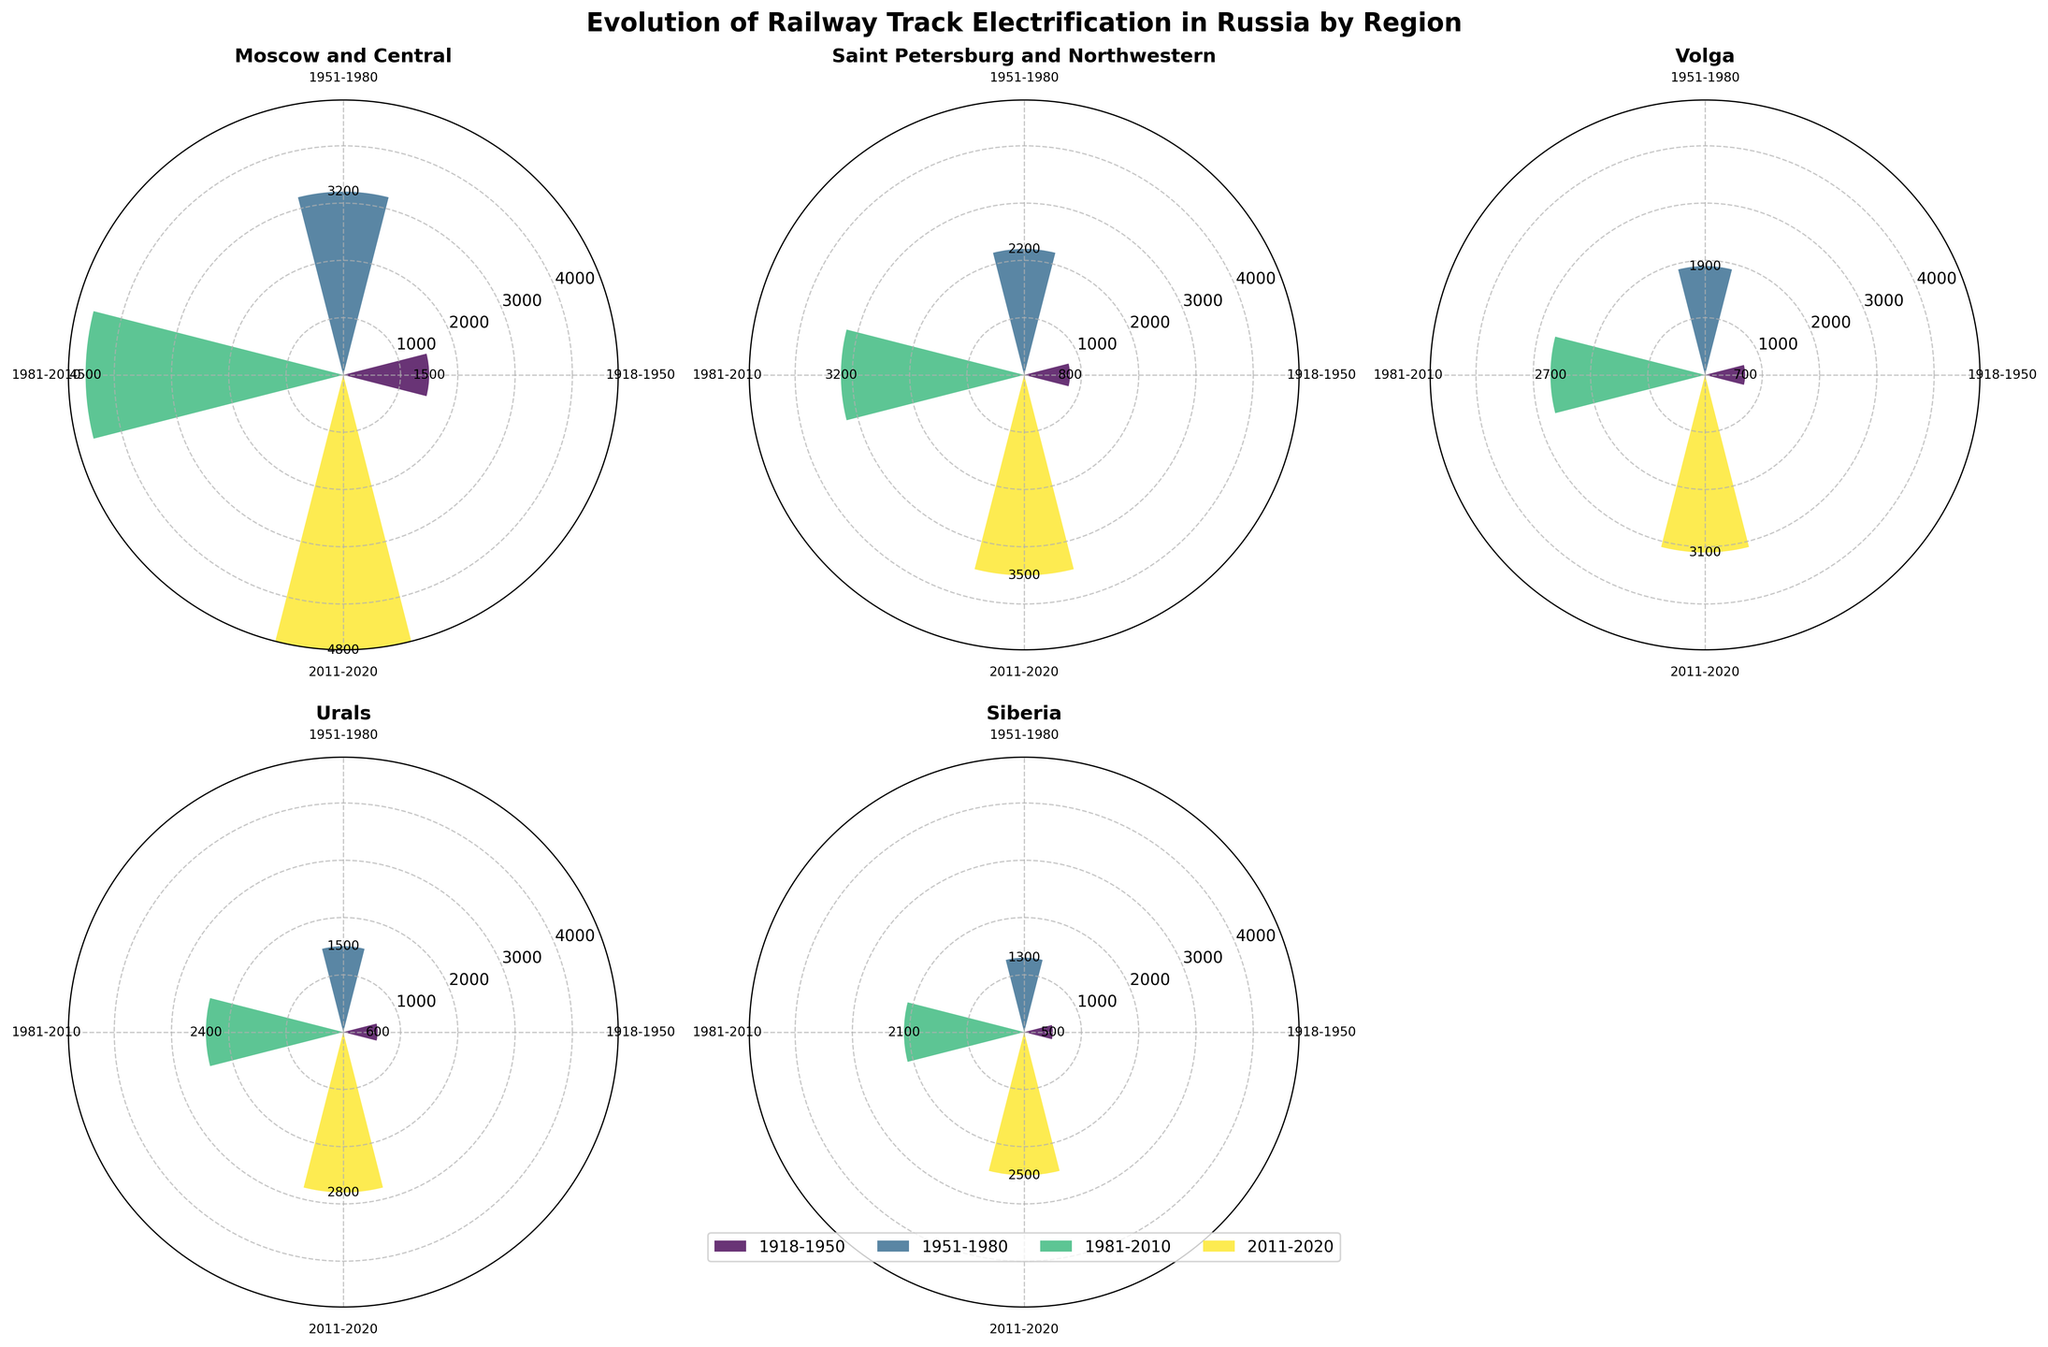What is the total length of electrified tracks in the Moscow and Central region for the period 1918-1950? The bar for the Moscow and Central region from 1918-1950 shows 1500 km of electrified tracks.
Answer: 1500 km Which region saw the largest increase in electrified tracks from 1918-1950 to 1951-1980? To determine the largest increase, calculate the difference between the two periods for each region. Moscow and Central increased from 1500 to 3200 km (+1700), Saint Petersburg and Northwestern from 800 to 2200 km (+1400), Volga from 700 to 1900 km (+1200), Urals from 600 to 1500 km (+900), Siberia from 500 to 1300 km (+800), and Far East from 300 to 900 km (+600). The largest increase is in the Moscow and Central region with an increase of 1700 km.
Answer: Moscow and Central How many time periods are displayed in the rose charts? Each subplot has bars representing four different time periods: 1918-1950, 1951-1980, 1981-2010, and 2011-2020. Therefore, there are four time periods displayed.
Answer: 4 Which region had the least electrified tracks in the 2011-2020 period? By comparing the 2011-2020 bars in all subplots, the Far East region has the least amount with 1900 km, while others are higher.
Answer: Far East Compare the electrified tracks in the Urals and Volga regions during the 1981-2010 period. Which one had more? The subplot for the Urals region shows 2400 km for the 1981-2010 period, while the Volga subplot shows 2700 km for the same period. Hence, the Volga region had more electrified tracks.
Answer: Volga What's the average length of electrified tracks in the Siberia region across all time periods? The lengths are 500, 1300, 2100, and 2500 km for the four periods in the Siberia region. The average is calculated as (500 + 1300 + 2100 + 2500) / 4 = 1600 km.
Answer: 1600 km Which two regions had equal length of electrified tracks in the 1981-2010 period? By examining the 1981-2010 bars in all subplots, Saint Petersburg and Northwestern, and Volga both have 3200 km of electrified tracks.
Answer: Saint Petersburg and Northwestern, Volga What trend do you observe in the length of electrified tracks in the Far East region from 1918-2020? The length of electrified tracks in the Far East region continuously increased across all periods: 300 km (1918-1950), 900 km (1951-1980), 1500 km (1981-2010), and 1900 km (2011-2020).
Answer: Continuous increase 